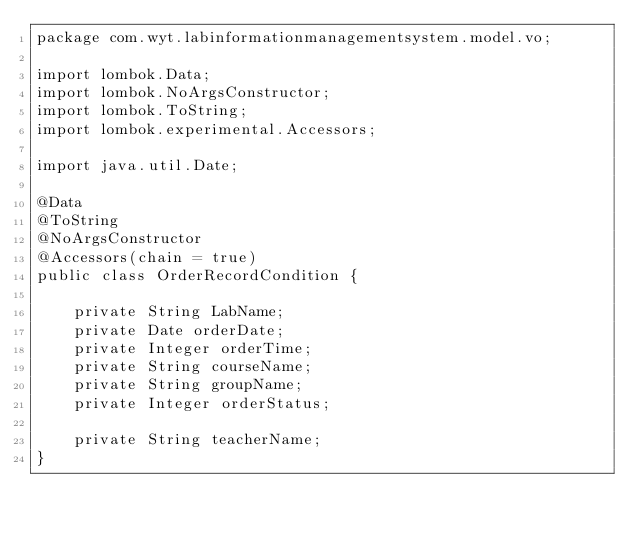Convert code to text. <code><loc_0><loc_0><loc_500><loc_500><_Java_>package com.wyt.labinformationmanagementsystem.model.vo;

import lombok.Data;
import lombok.NoArgsConstructor;
import lombok.ToString;
import lombok.experimental.Accessors;

import java.util.Date;

@Data
@ToString
@NoArgsConstructor
@Accessors(chain = true)
public class OrderRecordCondition {

    private String LabName;
    private Date orderDate;
    private Integer orderTime;
    private String courseName;
    private String groupName;
    private Integer orderStatus;

    private String teacherName;
}
</code> 